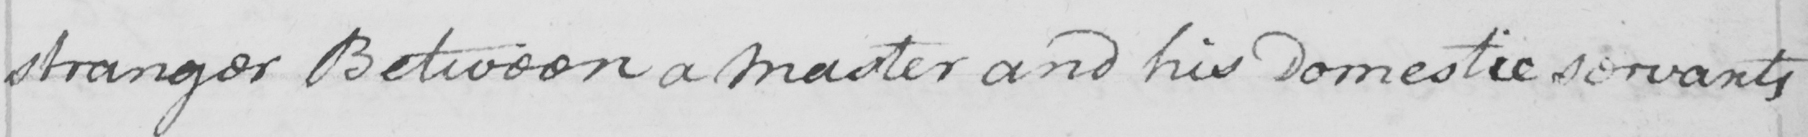Transcribe the text shown in this historical manuscript line. stranger Between a master and his Domestic servants 